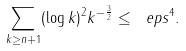<formula> <loc_0><loc_0><loc_500><loc_500>\sum _ { k \geq n + 1 } ( \log k ) ^ { 2 } k ^ { - \frac { 3 } { 2 } } \leq \ e p s ^ { 4 } .</formula> 